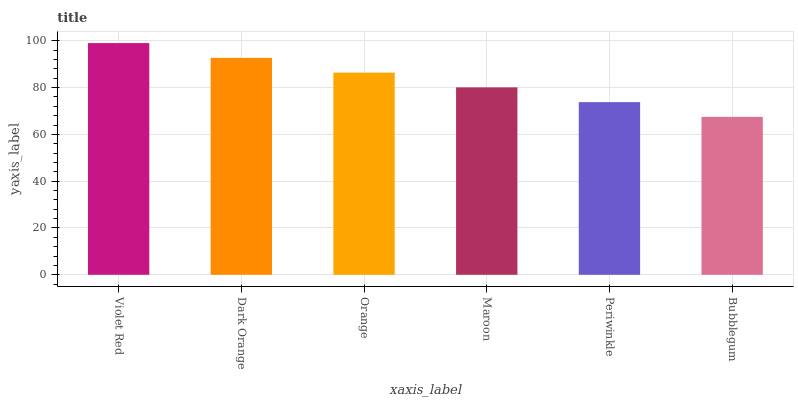Is Bubblegum the minimum?
Answer yes or no. Yes. Is Violet Red the maximum?
Answer yes or no. Yes. Is Dark Orange the minimum?
Answer yes or no. No. Is Dark Orange the maximum?
Answer yes or no. No. Is Violet Red greater than Dark Orange?
Answer yes or no. Yes. Is Dark Orange less than Violet Red?
Answer yes or no. Yes. Is Dark Orange greater than Violet Red?
Answer yes or no. No. Is Violet Red less than Dark Orange?
Answer yes or no. No. Is Orange the high median?
Answer yes or no. Yes. Is Maroon the low median?
Answer yes or no. Yes. Is Periwinkle the high median?
Answer yes or no. No. Is Bubblegum the low median?
Answer yes or no. No. 